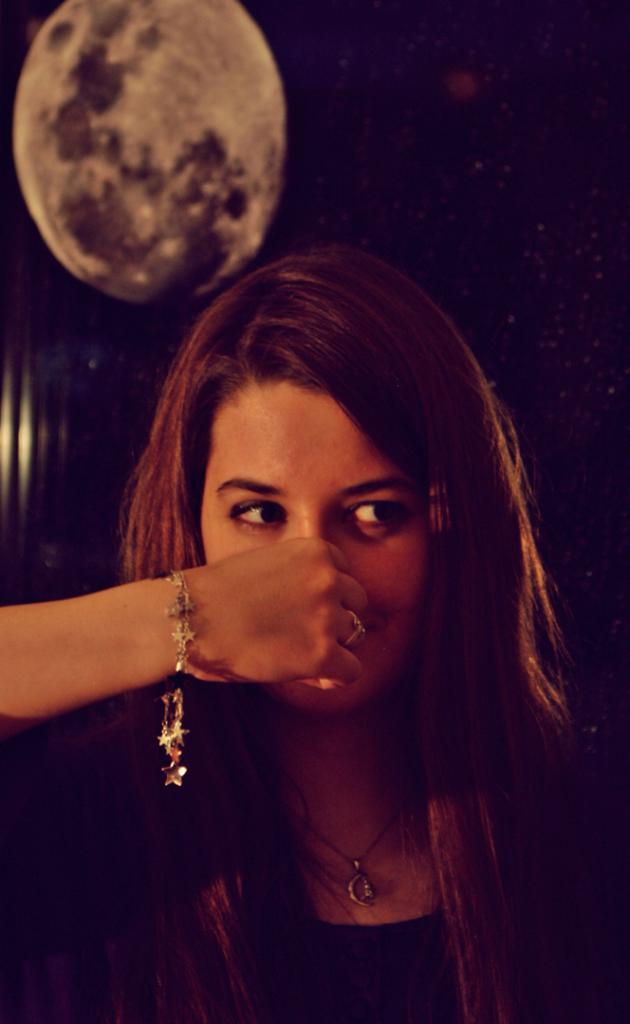Who is the main subject in the image? There is a woman in the image. What is the woman doing in the image? The woman is holding her nose. Can you describe the background of the image? The background of the image is blurred. What type of vein is being advertised in the image? There is no advertisement or vein present in the image; it features a woman holding her nose. What tool is the woman using to fix the wrench in the image? There is no wrench or tool present in the image; it only shows a woman holding her nose. 